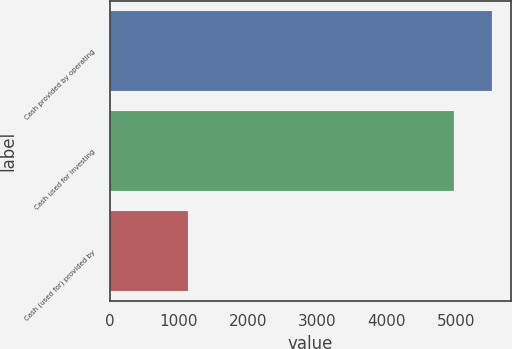Convert chart. <chart><loc_0><loc_0><loc_500><loc_500><bar_chart><fcel>Cash provided by operating<fcel>Cash used for investing<fcel>Cash (used for) provided by<nl><fcel>5520<fcel>4971<fcel>1139<nl></chart> 